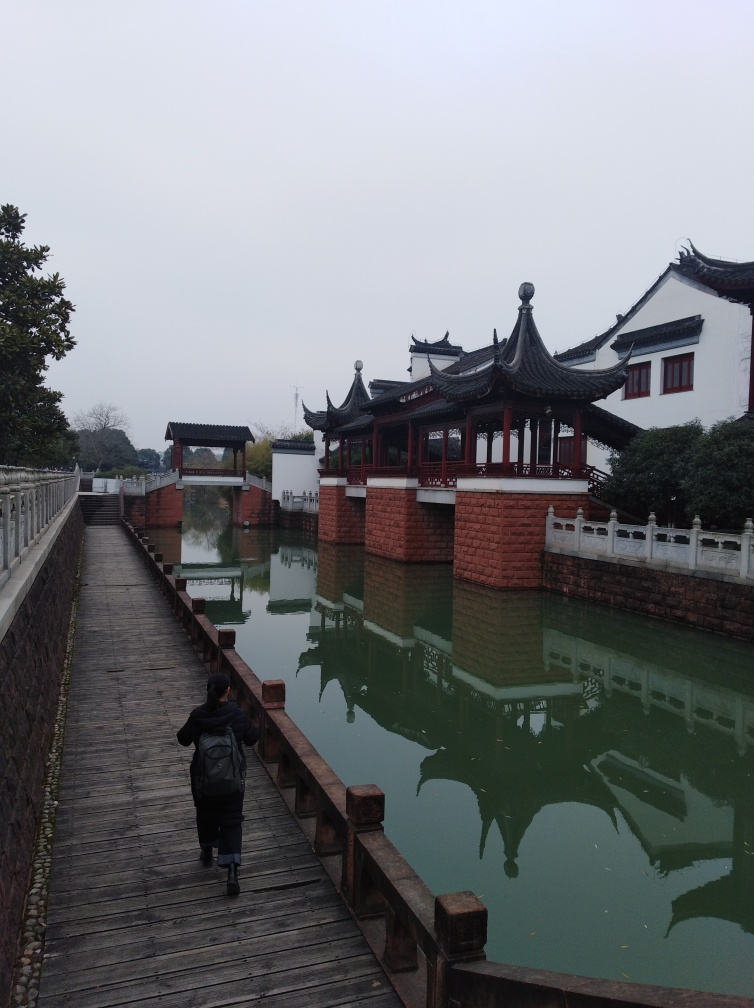What kind of mood does this image evoke? The image inspires a peaceful and serene mood, due in part to the tranquillity of the reflecting water, the gentle symmetry of the architecture, and the absence of bustling activity. The overall atmosphere appears contemplative and calm, inviting viewers to imagine the sounds of silence and perhaps distant water birds. 